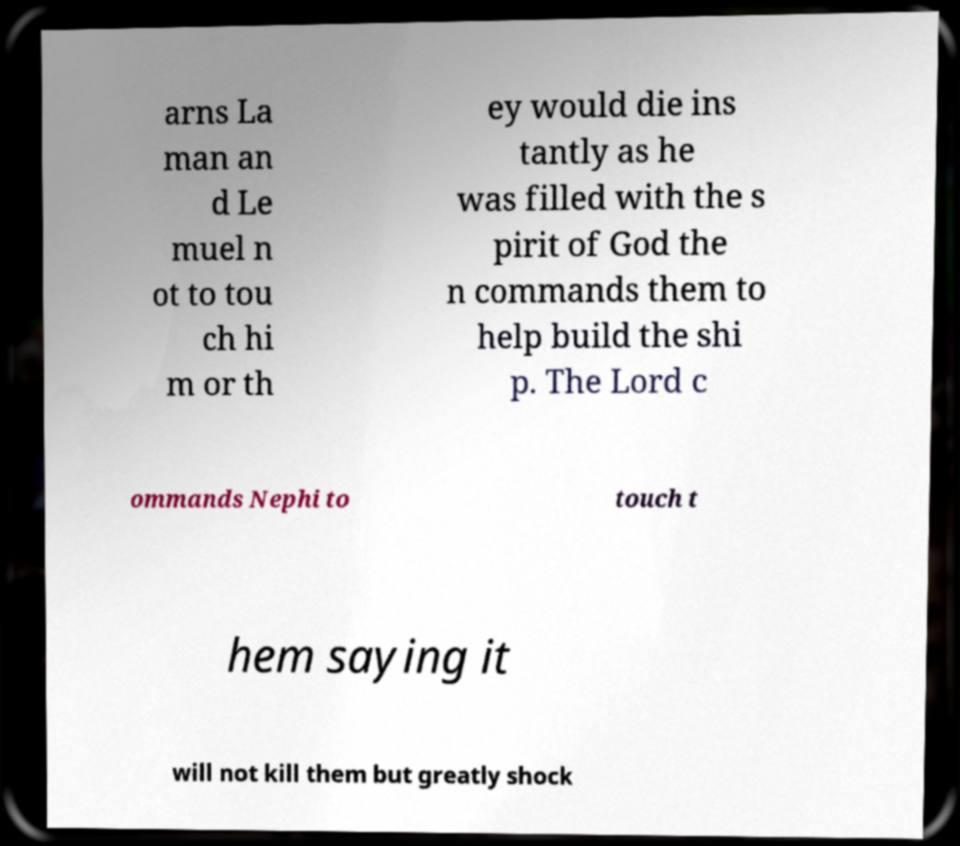Could you extract and type out the text from this image? arns La man an d Le muel n ot to tou ch hi m or th ey would die ins tantly as he was filled with the s pirit of God the n commands them to help build the shi p. The Lord c ommands Nephi to touch t hem saying it will not kill them but greatly shock 